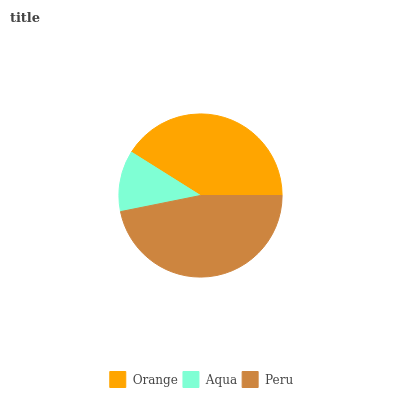Is Aqua the minimum?
Answer yes or no. Yes. Is Peru the maximum?
Answer yes or no. Yes. Is Peru the minimum?
Answer yes or no. No. Is Aqua the maximum?
Answer yes or no. No. Is Peru greater than Aqua?
Answer yes or no. Yes. Is Aqua less than Peru?
Answer yes or no. Yes. Is Aqua greater than Peru?
Answer yes or no. No. Is Peru less than Aqua?
Answer yes or no. No. Is Orange the high median?
Answer yes or no. Yes. Is Orange the low median?
Answer yes or no. Yes. Is Peru the high median?
Answer yes or no. No. Is Peru the low median?
Answer yes or no. No. 